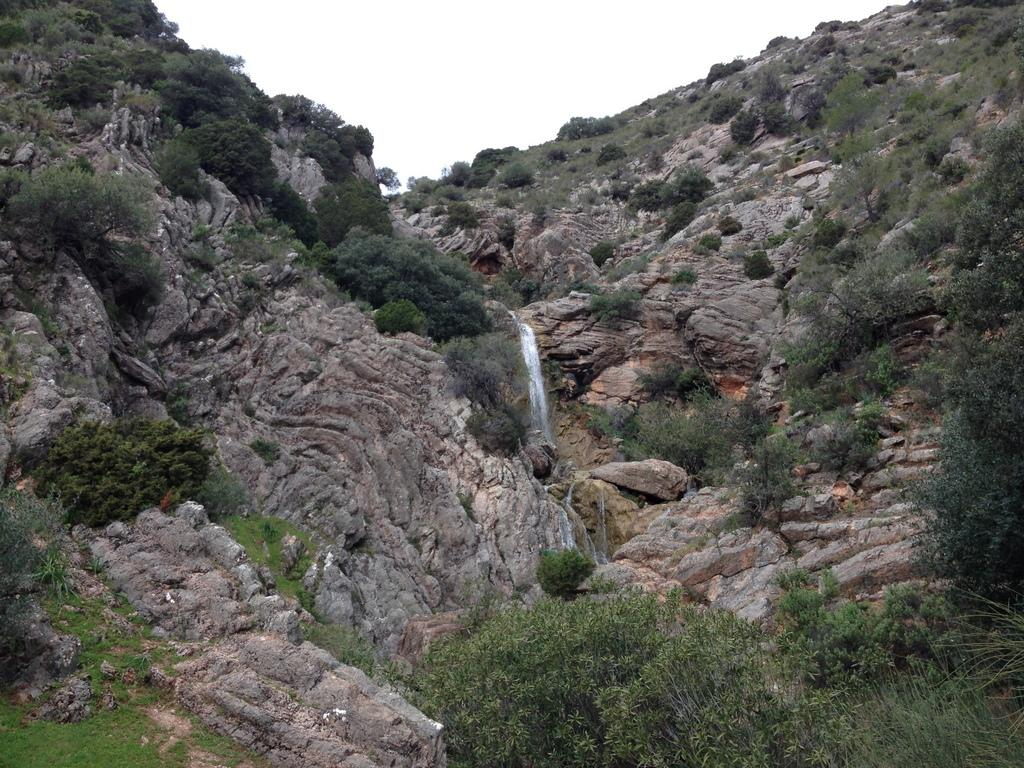What type of vegetation can be seen in the image? There are trees in the image. What type of ground cover is visible in the image? There is grass visible in the image. What other natural elements can be seen in the image? There are rocks in the image. What date is marked on the calendar in the image? There is no calendar present in the image. Can you describe the eye color of the person in the image? There is no person present in the image, so their eye color cannot be determined. 